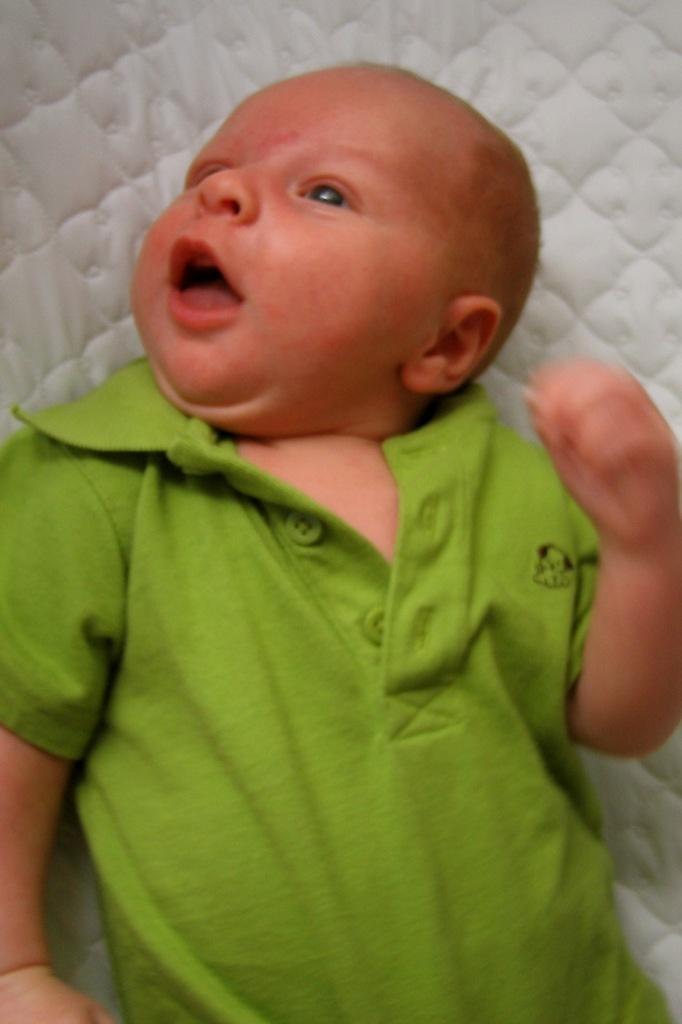Can you describe this image briefly? In the center of the image a baby is lying on the bed. 